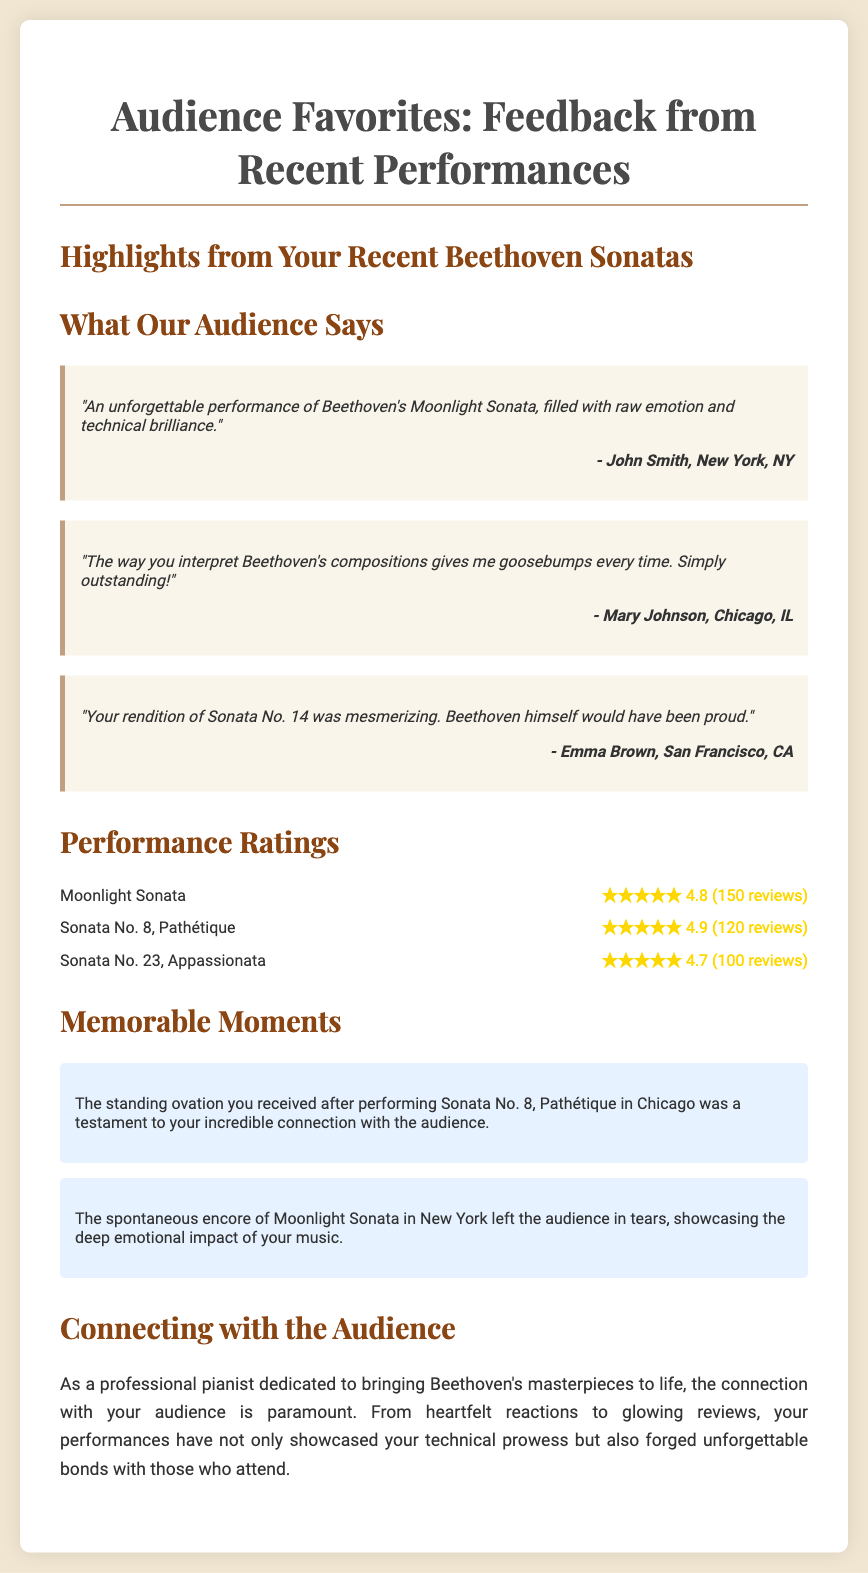What is the title of the poster? The title of the poster is prominently displayed at the top, introducing the theme of audience feedback and performance highlights.
Answer: Audience Favorites: Feedback from Recent Performances How many reviews did the Moonlight Sonata receive? The number of reviews is stated in the performance ratings section for Moonlight Sonata.
Answer: 150 reviews Who is quoted saying the performance was "filled with raw emotion and technical brilliance"? The quote mentioning raw emotion and technical brilliance is attributed to a specific individual, indicated in the quotes section.
Answer: John Smith What is the rating of Sonata No. 8, Pathétique? The rating appears in the performance ratings section, which presents the ratings for various sonatas.
Answer: 4.9 What memorable moment occurred in Chicago? The memorable moments section describes specific events that resonated with the audience during performances.
Answer: Standing ovation after Sonata No. 8, Pathétique How does the pianist feel about connecting with the audience? The spotlight section expresses thoughts regarding the importance of audience connection during performances.
Answer: Paramount Which sonata received the lowest rating? In the ratings section, the performances are listed along with their corresponding ratings, revealing the lowest among them.
Answer: Sonata No. 23, Appassionata What emotional impact did the encore of Moonlight Sonata have on the audience? The spontaneous encore's effect on the audience is noted in the memorable moments section, emphasizing its significance.
Answer: Left the audience in tears 